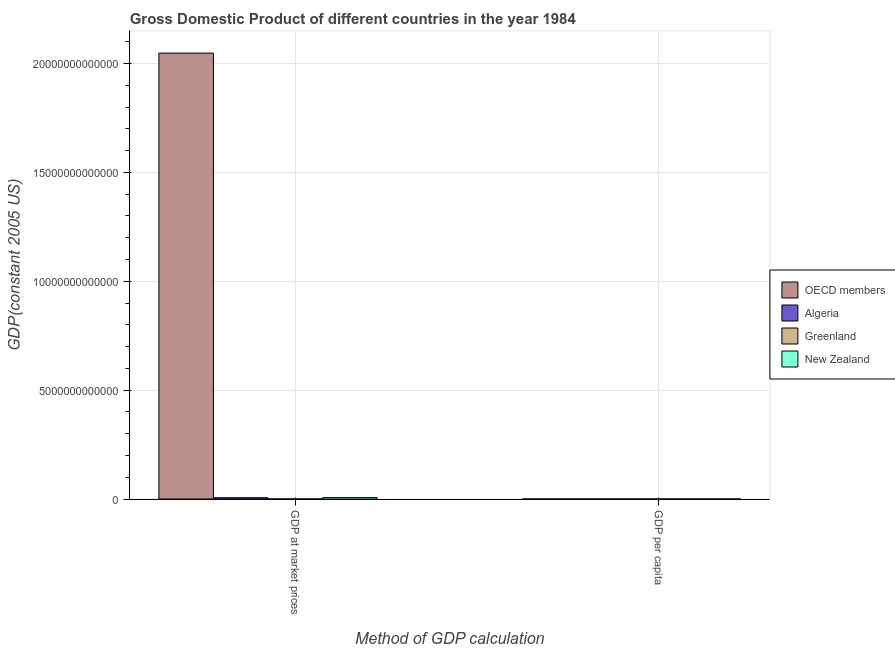How many different coloured bars are there?
Make the answer very short. 4. How many groups of bars are there?
Provide a short and direct response. 2. How many bars are there on the 2nd tick from the left?
Provide a succinct answer. 4. How many bars are there on the 1st tick from the right?
Offer a terse response. 4. What is the label of the 1st group of bars from the left?
Make the answer very short. GDP at market prices. What is the gdp per capita in New Zealand?
Ensure brevity in your answer.  2.06e+04. Across all countries, what is the maximum gdp per capita?
Make the answer very short. 2.22e+04. Across all countries, what is the minimum gdp per capita?
Offer a terse response. 2831.23. In which country was the gdp at market prices maximum?
Provide a short and direct response. OECD members. In which country was the gdp at market prices minimum?
Ensure brevity in your answer.  Greenland. What is the total gdp per capita in the graph?
Offer a very short reply. 6.58e+04. What is the difference between the gdp per capita in Greenland and that in Algeria?
Give a very brief answer. 1.94e+04. What is the difference between the gdp at market prices in New Zealand and the gdp per capita in Greenland?
Your response must be concise. 6.65e+1. What is the average gdp per capita per country?
Provide a succinct answer. 1.65e+04. What is the difference between the gdp per capita and gdp at market prices in New Zealand?
Offer a terse response. -6.65e+1. What is the ratio of the gdp per capita in Greenland to that in Algeria?
Your response must be concise. 7.86. In how many countries, is the gdp per capita greater than the average gdp per capita taken over all countries?
Your response must be concise. 3. What does the 1st bar from the right in GDP at market prices represents?
Make the answer very short. New Zealand. Are all the bars in the graph horizontal?
Your answer should be compact. No. How many countries are there in the graph?
Provide a short and direct response. 4. What is the difference between two consecutive major ticks on the Y-axis?
Your answer should be compact. 5.00e+12. Are the values on the major ticks of Y-axis written in scientific E-notation?
Provide a short and direct response. No. Does the graph contain grids?
Offer a very short reply. Yes. Where does the legend appear in the graph?
Ensure brevity in your answer.  Center right. What is the title of the graph?
Offer a very short reply. Gross Domestic Product of different countries in the year 1984. What is the label or title of the X-axis?
Your response must be concise. Method of GDP calculation. What is the label or title of the Y-axis?
Your response must be concise. GDP(constant 2005 US). What is the GDP(constant 2005 US) of OECD members in GDP at market prices?
Your answer should be compact. 2.05e+13. What is the GDP(constant 2005 US) in Algeria in GDP at market prices?
Keep it short and to the point. 6.20e+1. What is the GDP(constant 2005 US) in Greenland in GDP at market prices?
Provide a short and direct response. 1.17e+09. What is the GDP(constant 2005 US) in New Zealand in GDP at market prices?
Make the answer very short. 6.65e+1. What is the GDP(constant 2005 US) in OECD members in GDP per capita?
Offer a terse response. 2.01e+04. What is the GDP(constant 2005 US) of Algeria in GDP per capita?
Give a very brief answer. 2831.23. What is the GDP(constant 2005 US) of Greenland in GDP per capita?
Keep it short and to the point. 2.22e+04. What is the GDP(constant 2005 US) in New Zealand in GDP per capita?
Offer a very short reply. 2.06e+04. Across all Method of GDP calculation, what is the maximum GDP(constant 2005 US) of OECD members?
Your answer should be compact. 2.05e+13. Across all Method of GDP calculation, what is the maximum GDP(constant 2005 US) of Algeria?
Ensure brevity in your answer.  6.20e+1. Across all Method of GDP calculation, what is the maximum GDP(constant 2005 US) of Greenland?
Make the answer very short. 1.17e+09. Across all Method of GDP calculation, what is the maximum GDP(constant 2005 US) in New Zealand?
Your answer should be compact. 6.65e+1. Across all Method of GDP calculation, what is the minimum GDP(constant 2005 US) in OECD members?
Ensure brevity in your answer.  2.01e+04. Across all Method of GDP calculation, what is the minimum GDP(constant 2005 US) in Algeria?
Offer a terse response. 2831.23. Across all Method of GDP calculation, what is the minimum GDP(constant 2005 US) in Greenland?
Give a very brief answer. 2.22e+04. Across all Method of GDP calculation, what is the minimum GDP(constant 2005 US) of New Zealand?
Your response must be concise. 2.06e+04. What is the total GDP(constant 2005 US) in OECD members in the graph?
Keep it short and to the point. 2.05e+13. What is the total GDP(constant 2005 US) in Algeria in the graph?
Give a very brief answer. 6.20e+1. What is the total GDP(constant 2005 US) in Greenland in the graph?
Your answer should be very brief. 1.17e+09. What is the total GDP(constant 2005 US) in New Zealand in the graph?
Your answer should be compact. 6.65e+1. What is the difference between the GDP(constant 2005 US) in OECD members in GDP at market prices and that in GDP per capita?
Your answer should be compact. 2.05e+13. What is the difference between the GDP(constant 2005 US) of Algeria in GDP at market prices and that in GDP per capita?
Your answer should be compact. 6.20e+1. What is the difference between the GDP(constant 2005 US) of Greenland in GDP at market prices and that in GDP per capita?
Keep it short and to the point. 1.17e+09. What is the difference between the GDP(constant 2005 US) of New Zealand in GDP at market prices and that in GDP per capita?
Your response must be concise. 6.65e+1. What is the difference between the GDP(constant 2005 US) in OECD members in GDP at market prices and the GDP(constant 2005 US) in Algeria in GDP per capita?
Provide a short and direct response. 2.05e+13. What is the difference between the GDP(constant 2005 US) of OECD members in GDP at market prices and the GDP(constant 2005 US) of Greenland in GDP per capita?
Keep it short and to the point. 2.05e+13. What is the difference between the GDP(constant 2005 US) in OECD members in GDP at market prices and the GDP(constant 2005 US) in New Zealand in GDP per capita?
Your answer should be very brief. 2.05e+13. What is the difference between the GDP(constant 2005 US) in Algeria in GDP at market prices and the GDP(constant 2005 US) in Greenland in GDP per capita?
Your answer should be compact. 6.20e+1. What is the difference between the GDP(constant 2005 US) in Algeria in GDP at market prices and the GDP(constant 2005 US) in New Zealand in GDP per capita?
Give a very brief answer. 6.20e+1. What is the difference between the GDP(constant 2005 US) in Greenland in GDP at market prices and the GDP(constant 2005 US) in New Zealand in GDP per capita?
Make the answer very short. 1.17e+09. What is the average GDP(constant 2005 US) in OECD members per Method of GDP calculation?
Your answer should be very brief. 1.02e+13. What is the average GDP(constant 2005 US) of Algeria per Method of GDP calculation?
Provide a succinct answer. 3.10e+1. What is the average GDP(constant 2005 US) in Greenland per Method of GDP calculation?
Your answer should be compact. 5.86e+08. What is the average GDP(constant 2005 US) in New Zealand per Method of GDP calculation?
Provide a succinct answer. 3.32e+1. What is the difference between the GDP(constant 2005 US) of OECD members and GDP(constant 2005 US) of Algeria in GDP at market prices?
Provide a short and direct response. 2.04e+13. What is the difference between the GDP(constant 2005 US) of OECD members and GDP(constant 2005 US) of Greenland in GDP at market prices?
Give a very brief answer. 2.05e+13. What is the difference between the GDP(constant 2005 US) of OECD members and GDP(constant 2005 US) of New Zealand in GDP at market prices?
Provide a short and direct response. 2.04e+13. What is the difference between the GDP(constant 2005 US) in Algeria and GDP(constant 2005 US) in Greenland in GDP at market prices?
Offer a terse response. 6.08e+1. What is the difference between the GDP(constant 2005 US) in Algeria and GDP(constant 2005 US) in New Zealand in GDP at market prices?
Make the answer very short. -4.50e+09. What is the difference between the GDP(constant 2005 US) of Greenland and GDP(constant 2005 US) of New Zealand in GDP at market prices?
Give a very brief answer. -6.53e+1. What is the difference between the GDP(constant 2005 US) in OECD members and GDP(constant 2005 US) in Algeria in GDP per capita?
Provide a short and direct response. 1.73e+04. What is the difference between the GDP(constant 2005 US) of OECD members and GDP(constant 2005 US) of Greenland in GDP per capita?
Keep it short and to the point. -2115.58. What is the difference between the GDP(constant 2005 US) of OECD members and GDP(constant 2005 US) of New Zealand in GDP per capita?
Keep it short and to the point. -476.1. What is the difference between the GDP(constant 2005 US) of Algeria and GDP(constant 2005 US) of Greenland in GDP per capita?
Ensure brevity in your answer.  -1.94e+04. What is the difference between the GDP(constant 2005 US) of Algeria and GDP(constant 2005 US) of New Zealand in GDP per capita?
Your response must be concise. -1.78e+04. What is the difference between the GDP(constant 2005 US) of Greenland and GDP(constant 2005 US) of New Zealand in GDP per capita?
Keep it short and to the point. 1639.48. What is the ratio of the GDP(constant 2005 US) in OECD members in GDP at market prices to that in GDP per capita?
Give a very brief answer. 1.02e+09. What is the ratio of the GDP(constant 2005 US) of Algeria in GDP at market prices to that in GDP per capita?
Your answer should be very brief. 2.19e+07. What is the ratio of the GDP(constant 2005 US) of Greenland in GDP at market prices to that in GDP per capita?
Your answer should be very brief. 5.27e+04. What is the ratio of the GDP(constant 2005 US) in New Zealand in GDP at market prices to that in GDP per capita?
Make the answer very short. 3.23e+06. What is the difference between the highest and the second highest GDP(constant 2005 US) of OECD members?
Your answer should be compact. 2.05e+13. What is the difference between the highest and the second highest GDP(constant 2005 US) in Algeria?
Provide a short and direct response. 6.20e+1. What is the difference between the highest and the second highest GDP(constant 2005 US) in Greenland?
Provide a short and direct response. 1.17e+09. What is the difference between the highest and the second highest GDP(constant 2005 US) in New Zealand?
Your answer should be very brief. 6.65e+1. What is the difference between the highest and the lowest GDP(constant 2005 US) in OECD members?
Ensure brevity in your answer.  2.05e+13. What is the difference between the highest and the lowest GDP(constant 2005 US) of Algeria?
Keep it short and to the point. 6.20e+1. What is the difference between the highest and the lowest GDP(constant 2005 US) in Greenland?
Make the answer very short. 1.17e+09. What is the difference between the highest and the lowest GDP(constant 2005 US) of New Zealand?
Offer a terse response. 6.65e+1. 